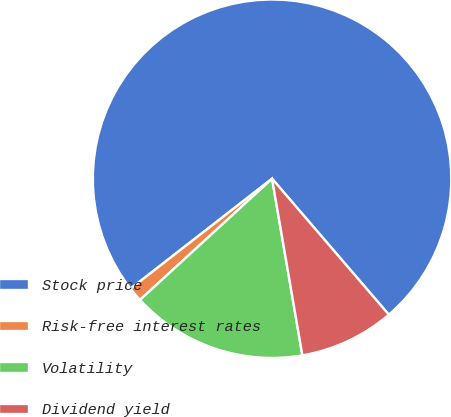Convert chart. <chart><loc_0><loc_0><loc_500><loc_500><pie_chart><fcel>Stock price<fcel>Risk-free interest rates<fcel>Volatility<fcel>Dividend yield<nl><fcel>74.23%<fcel>1.3%<fcel>15.89%<fcel>8.59%<nl></chart> 